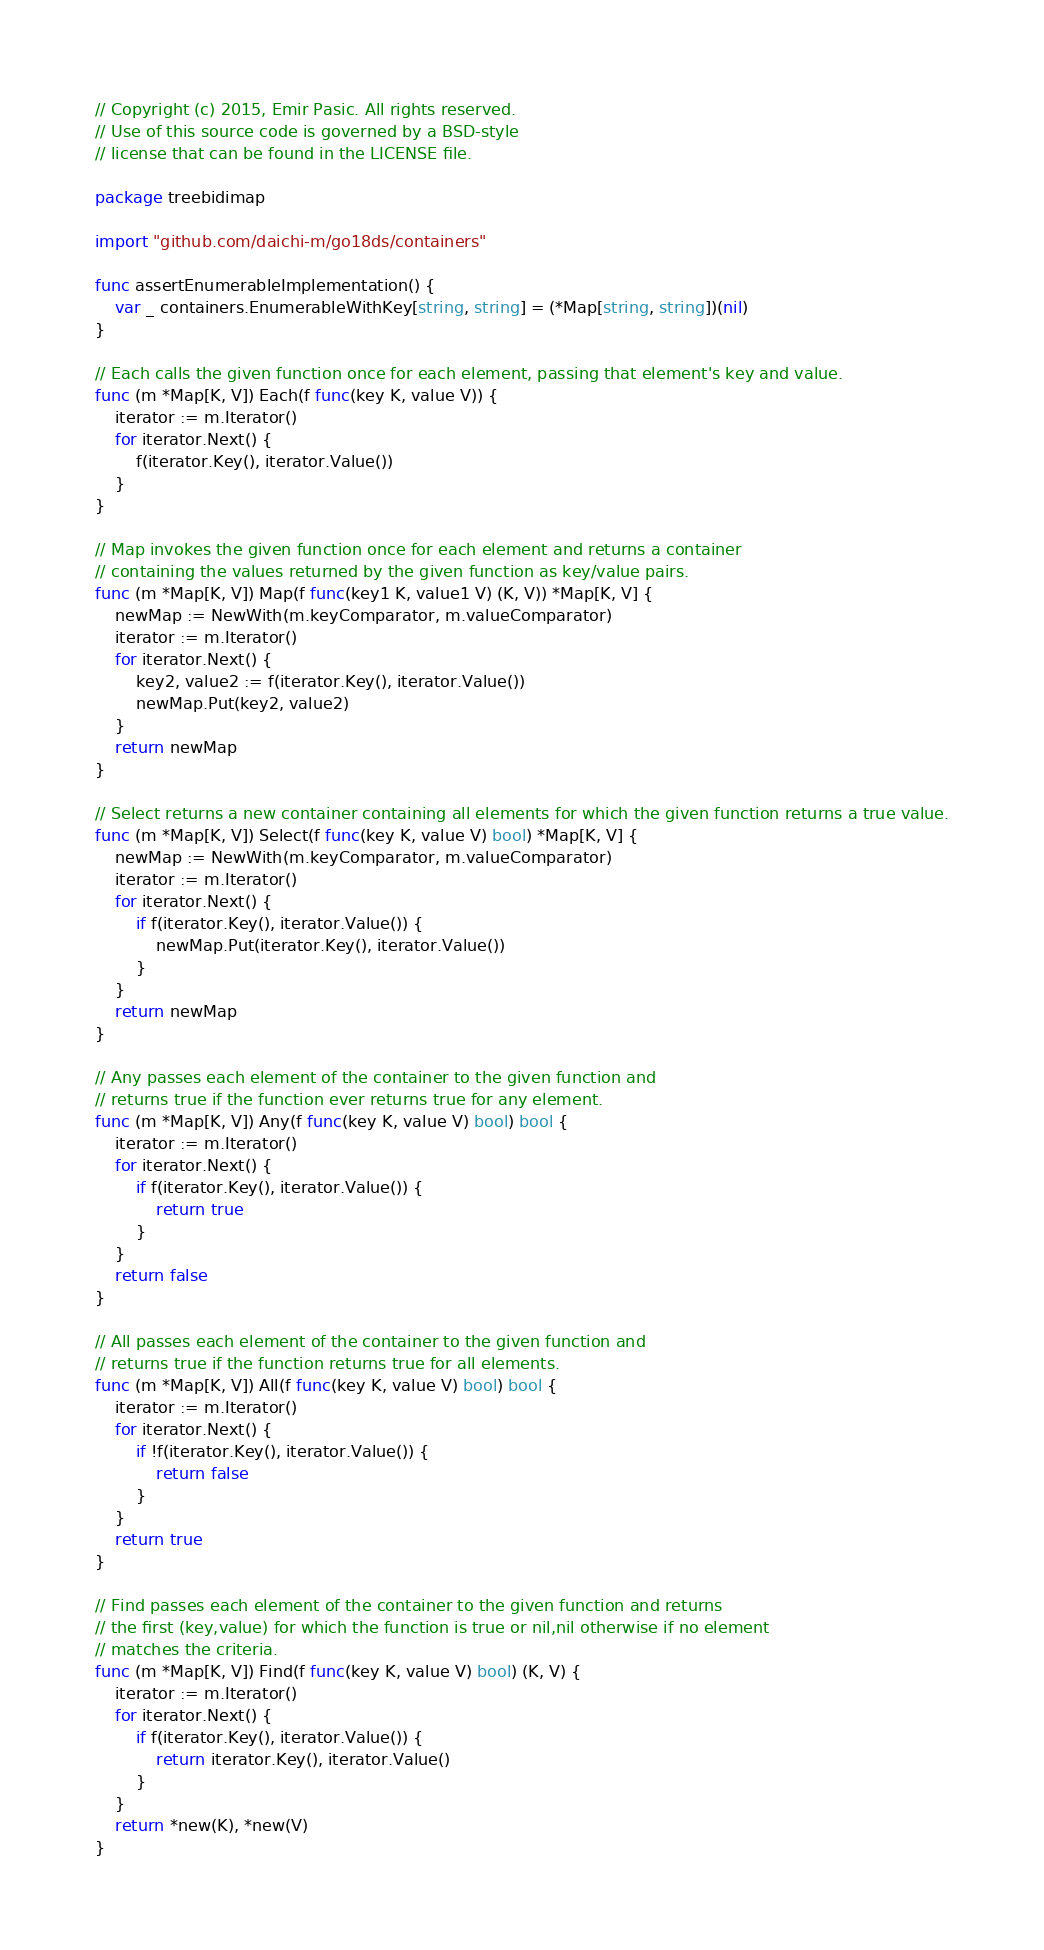<code> <loc_0><loc_0><loc_500><loc_500><_Go_>// Copyright (c) 2015, Emir Pasic. All rights reserved.
// Use of this source code is governed by a BSD-style
// license that can be found in the LICENSE file.

package treebidimap

import "github.com/daichi-m/go18ds/containers"

func assertEnumerableImplementation() {
	var _ containers.EnumerableWithKey[string, string] = (*Map[string, string])(nil)
}

// Each calls the given function once for each element, passing that element's key and value.
func (m *Map[K, V]) Each(f func(key K, value V)) {
	iterator := m.Iterator()
	for iterator.Next() {
		f(iterator.Key(), iterator.Value())
	}
}

// Map invokes the given function once for each element and returns a container
// containing the values returned by the given function as key/value pairs.
func (m *Map[K, V]) Map(f func(key1 K, value1 V) (K, V)) *Map[K, V] {
	newMap := NewWith(m.keyComparator, m.valueComparator)
	iterator := m.Iterator()
	for iterator.Next() {
		key2, value2 := f(iterator.Key(), iterator.Value())
		newMap.Put(key2, value2)
	}
	return newMap
}

// Select returns a new container containing all elements for which the given function returns a true value.
func (m *Map[K, V]) Select(f func(key K, value V) bool) *Map[K, V] {
	newMap := NewWith(m.keyComparator, m.valueComparator)
	iterator := m.Iterator()
	for iterator.Next() {
		if f(iterator.Key(), iterator.Value()) {
			newMap.Put(iterator.Key(), iterator.Value())
		}
	}
	return newMap
}

// Any passes each element of the container to the given function and
// returns true if the function ever returns true for any element.
func (m *Map[K, V]) Any(f func(key K, value V) bool) bool {
	iterator := m.Iterator()
	for iterator.Next() {
		if f(iterator.Key(), iterator.Value()) {
			return true
		}
	}
	return false
}

// All passes each element of the container to the given function and
// returns true if the function returns true for all elements.
func (m *Map[K, V]) All(f func(key K, value V) bool) bool {
	iterator := m.Iterator()
	for iterator.Next() {
		if !f(iterator.Key(), iterator.Value()) {
			return false
		}
	}
	return true
}

// Find passes each element of the container to the given function and returns
// the first (key,value) for which the function is true or nil,nil otherwise if no element
// matches the criteria.
func (m *Map[K, V]) Find(f func(key K, value V) bool) (K, V) {
	iterator := m.Iterator()
	for iterator.Next() {
		if f(iterator.Key(), iterator.Value()) {
			return iterator.Key(), iterator.Value()
		}
	}
	return *new(K), *new(V)
}
</code> 